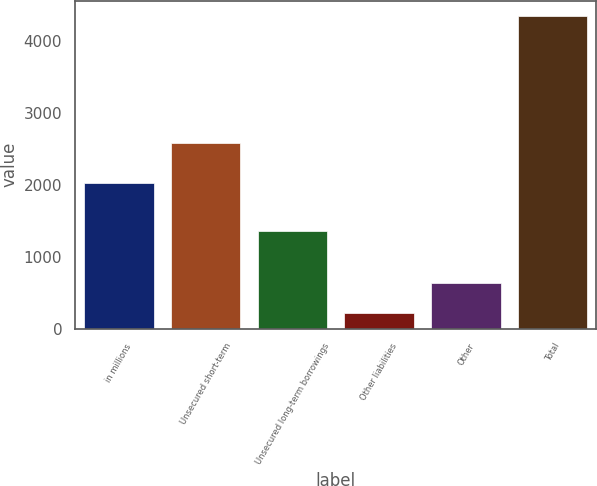Convert chart. <chart><loc_0><loc_0><loc_500><loc_500><bar_chart><fcel>in millions<fcel>Unsecured short-term<fcel>Unsecured long-term borrowings<fcel>Other liabilities<fcel>Other<fcel>Total<nl><fcel>2017<fcel>2585<fcel>1357<fcel>222<fcel>633.8<fcel>4340<nl></chart> 